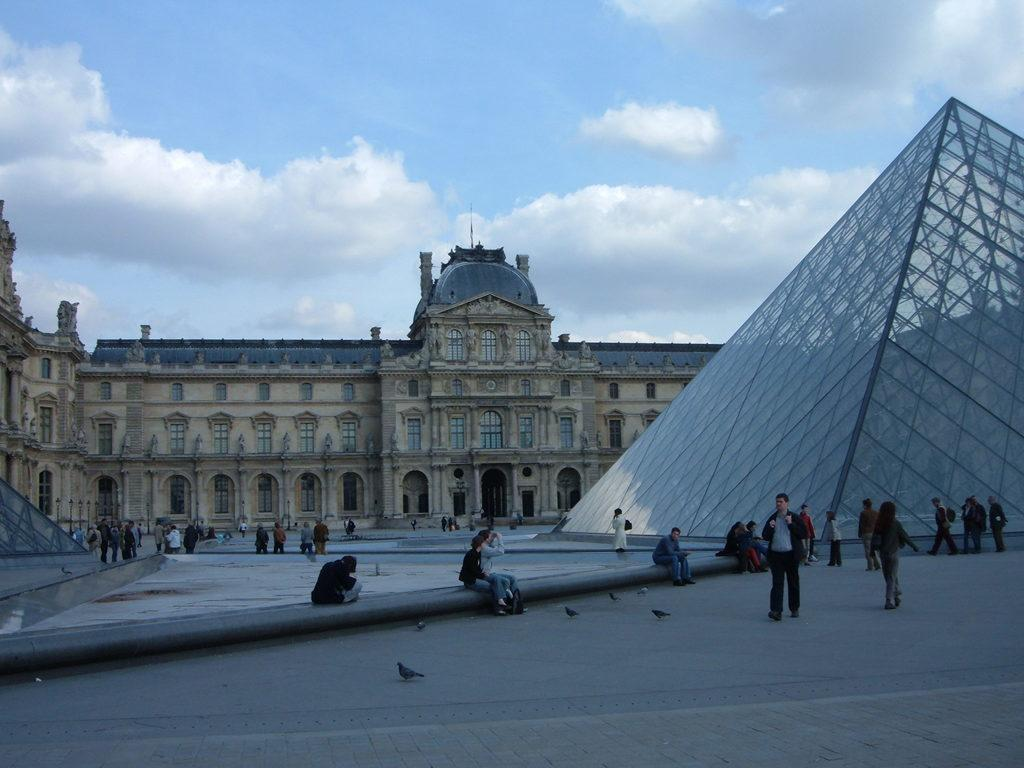What type of structure is visible in the image? There is a building with windows in the image. What are the people in the image doing? People are sitting and walking in the image. Can you describe the bird in the image? There is a bird in the image. What can be seen in the sky in the image? The sky is visible in the image. What is the opinion of the water in the image? There is no water present in the image, so it is not possible to determine its opinion. 